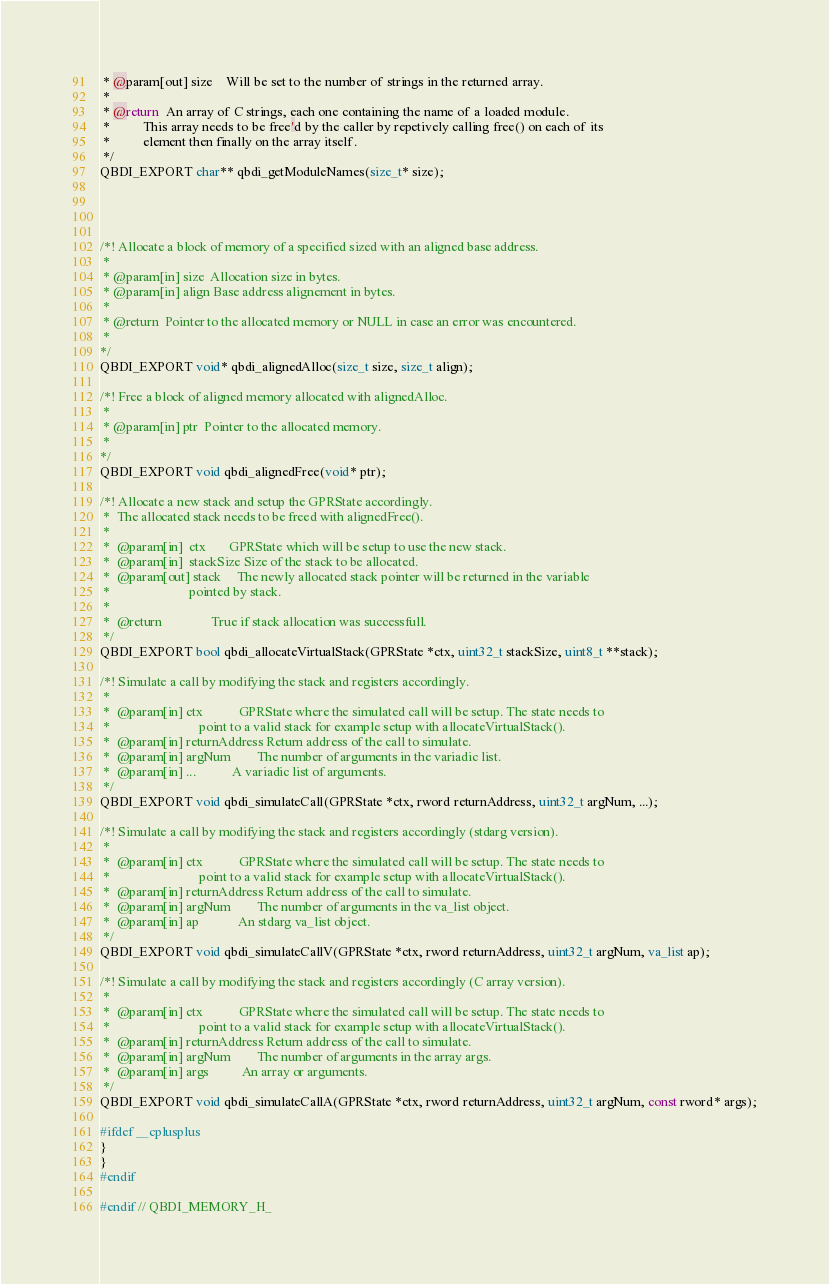Convert code to text. <code><loc_0><loc_0><loc_500><loc_500><_C_> * @param[out] size    Will be set to the number of strings in the returned array.
 *
 * @return  An array of C strings, each one containing the name of a loaded module.
 *          This array needs to be free'd by the caller by repetively calling free() on each of its
 *          element then finally on the array itself.
 */
QBDI_EXPORT char** qbdi_getModuleNames(size_t* size);




/*! Allocate a block of memory of a specified sized with an aligned base address.
 *
 * @param[in] size  Allocation size in bytes.
 * @param[in] align Base address alignement in bytes.
 *
 * @return  Pointer to the allocated memory or NULL in case an error was encountered.
 *
*/
QBDI_EXPORT void* qbdi_alignedAlloc(size_t size, size_t align);

/*! Free a block of aligned memory allocated with alignedAlloc.
 *
 * @param[in] ptr  Pointer to the allocated memory.
 *
*/
QBDI_EXPORT void qbdi_alignedFree(void* ptr);

/*! Allocate a new stack and setup the GPRState accordingly.
 *  The allocated stack needs to be freed with alignedFree().
 *
 *  @param[in]  ctx       GPRState which will be setup to use the new stack.
 *  @param[in]  stackSize Size of the stack to be allocated.
 *  @param[out] stack     The newly allocated stack pointer will be returned in the variable
 *                        pointed by stack.
 *
 *  @return               True if stack allocation was successfull.
 */
QBDI_EXPORT bool qbdi_allocateVirtualStack(GPRState *ctx, uint32_t stackSize, uint8_t **stack);

/*! Simulate a call by modifying the stack and registers accordingly.
 *
 *  @param[in] ctx           GPRState where the simulated call will be setup. The state needs to
 *                           point to a valid stack for example setup with allocateVirtualStack().
 *  @param[in] returnAddress Return address of the call to simulate.
 *  @param[in] argNum        The number of arguments in the variadic list.
 *  @param[in] ...           A variadic list of arguments.
 */
QBDI_EXPORT void qbdi_simulateCall(GPRState *ctx, rword returnAddress, uint32_t argNum, ...);

/*! Simulate a call by modifying the stack and registers accordingly (stdarg version).
 *
 *  @param[in] ctx           GPRState where the simulated call will be setup. The state needs to
 *                           point to a valid stack for example setup with allocateVirtualStack().
 *  @param[in] returnAddress Return address of the call to simulate.
 *  @param[in] argNum        The number of arguments in the va_list object.
 *  @param[in] ap            An stdarg va_list object.
 */
QBDI_EXPORT void qbdi_simulateCallV(GPRState *ctx, rword returnAddress, uint32_t argNum, va_list ap);

/*! Simulate a call by modifying the stack and registers accordingly (C array version).
 *
 *  @param[in] ctx           GPRState where the simulated call will be setup. The state needs to
 *                           point to a valid stack for example setup with allocateVirtualStack().
 *  @param[in] returnAddress Return address of the call to simulate.
 *  @param[in] argNum        The number of arguments in the array args.
 *  @param[in] args          An array or arguments.
 */
QBDI_EXPORT void qbdi_simulateCallA(GPRState *ctx, rword returnAddress, uint32_t argNum, const rword* args);

#ifdef __cplusplus
}
}
#endif

#endif // QBDI_MEMORY_H_
</code> 